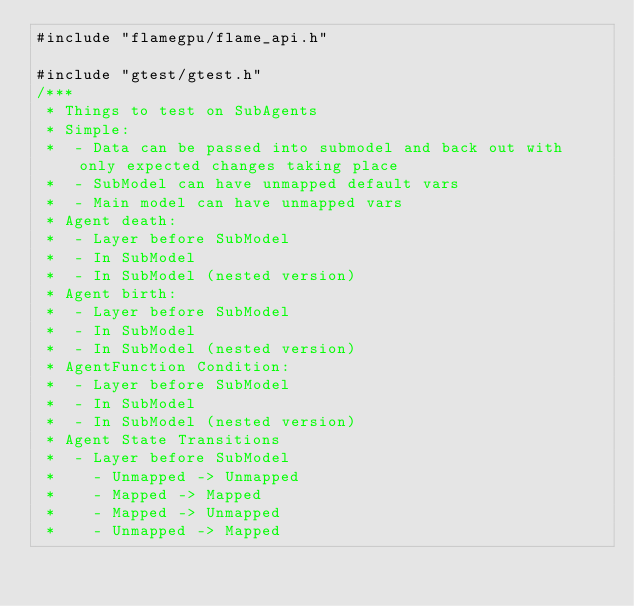Convert code to text. <code><loc_0><loc_0><loc_500><loc_500><_Cuda_>#include "flamegpu/flame_api.h"

#include "gtest/gtest.h"
/***
 * Things to test on SubAgents
 * Simple:
 *  - Data can be passed into submodel and back out with only expected changes taking place
 *  - SubModel can have unmapped default vars
 *  - Main model can have unmapped vars
 * Agent death:
 *  - Layer before SubModel
 *  - In SubModel
 *  - In SubModel (nested version)
 * Agent birth:
 *  - Layer before SubModel
 *  - In SubModel
 *  - In SubModel (nested version)
 * AgentFunction Condition:
 *  - Layer before SubModel
 *  - In SubModel
 *  - In SubModel (nested version)
 * Agent State Transitions
 *  - Layer before SubModel
 *    - Unmapped -> Unmapped
 *    - Mapped -> Mapped
 *    - Mapped -> Unmapped
 *    - Unmapped -> Mapped</code> 